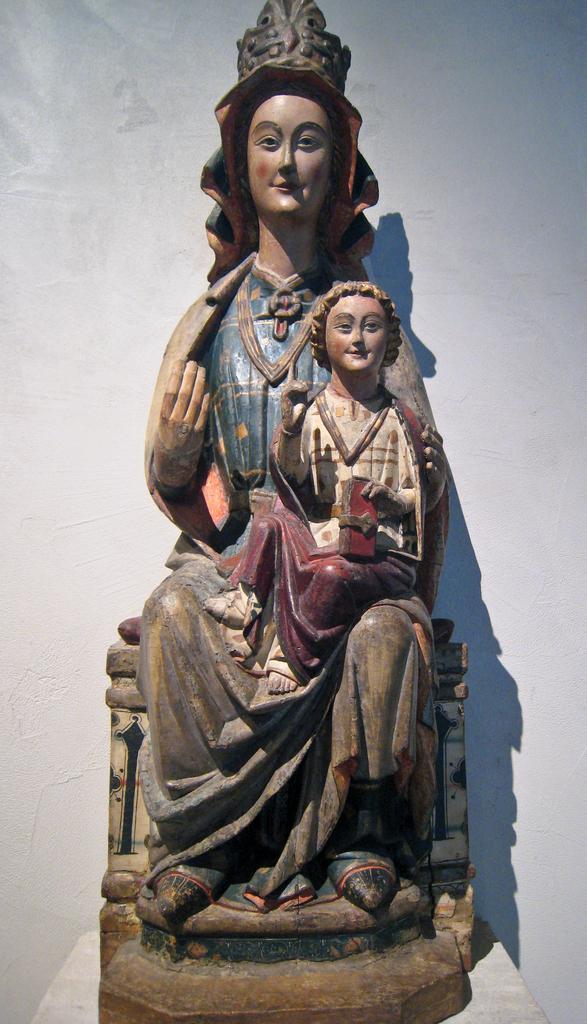How would you summarize this image in a sentence or two? In this image we can see sculptures and we can also see the white background. 